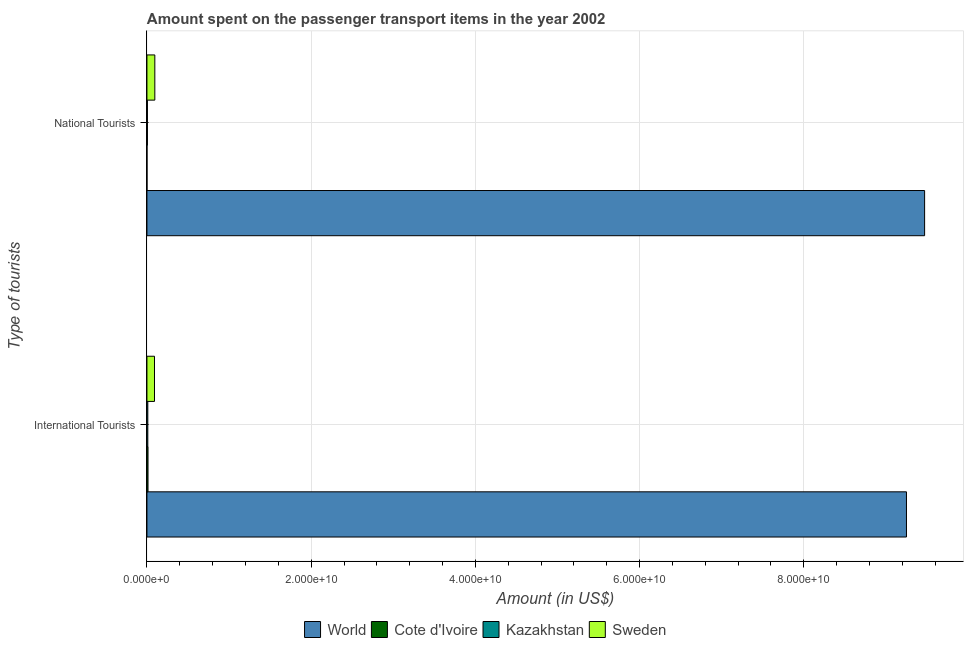How many different coloured bars are there?
Provide a short and direct response. 4. How many groups of bars are there?
Give a very brief answer. 2. How many bars are there on the 2nd tick from the top?
Keep it short and to the point. 4. How many bars are there on the 2nd tick from the bottom?
Give a very brief answer. 4. What is the label of the 1st group of bars from the top?
Offer a terse response. National Tourists. What is the amount spent on transport items of national tourists in Kazakhstan?
Your answer should be compact. 5.80e+07. Across all countries, what is the maximum amount spent on transport items of national tourists?
Give a very brief answer. 9.47e+1. Across all countries, what is the minimum amount spent on transport items of international tourists?
Give a very brief answer. 1.06e+08. In which country was the amount spent on transport items of international tourists maximum?
Provide a short and direct response. World. In which country was the amount spent on transport items of international tourists minimum?
Provide a succinct answer. Kazakhstan. What is the total amount spent on transport items of national tourists in the graph?
Provide a short and direct response. 9.57e+1. What is the difference between the amount spent on transport items of international tourists in Kazakhstan and that in Sweden?
Offer a very short reply. -8.14e+08. What is the difference between the amount spent on transport items of international tourists in World and the amount spent on transport items of national tourists in Cote d'Ivoire?
Your answer should be compact. 9.25e+1. What is the average amount spent on transport items of international tourists per country?
Give a very brief answer. 2.34e+1. What is the difference between the amount spent on transport items of national tourists and amount spent on transport items of international tourists in Sweden?
Your answer should be very brief. 4.10e+07. In how many countries, is the amount spent on transport items of national tourists greater than 16000000000 US$?
Provide a short and direct response. 1. What is the ratio of the amount spent on transport items of international tourists in World to that in Kazakhstan?
Give a very brief answer. 872.7. Is the amount spent on transport items of international tourists in Sweden less than that in Cote d'Ivoire?
Offer a terse response. No. In how many countries, is the amount spent on transport items of national tourists greater than the average amount spent on transport items of national tourists taken over all countries?
Your answer should be very brief. 1. What does the 3rd bar from the top in National Tourists represents?
Your answer should be compact. Cote d'Ivoire. How many bars are there?
Your answer should be very brief. 8. How many countries are there in the graph?
Ensure brevity in your answer.  4. What is the difference between two consecutive major ticks on the X-axis?
Your answer should be compact. 2.00e+1. Are the values on the major ticks of X-axis written in scientific E-notation?
Ensure brevity in your answer.  Yes. Does the graph contain grids?
Offer a very short reply. Yes. Where does the legend appear in the graph?
Offer a terse response. Bottom center. How are the legend labels stacked?
Make the answer very short. Horizontal. What is the title of the graph?
Give a very brief answer. Amount spent on the passenger transport items in the year 2002. Does "Canada" appear as one of the legend labels in the graph?
Keep it short and to the point. No. What is the label or title of the X-axis?
Your answer should be compact. Amount (in US$). What is the label or title of the Y-axis?
Give a very brief answer. Type of tourists. What is the Amount (in US$) in World in International Tourists?
Offer a very short reply. 9.25e+1. What is the Amount (in US$) in Cote d'Ivoire in International Tourists?
Your answer should be compact. 1.32e+08. What is the Amount (in US$) of Kazakhstan in International Tourists?
Make the answer very short. 1.06e+08. What is the Amount (in US$) of Sweden in International Tourists?
Keep it short and to the point. 9.20e+08. What is the Amount (in US$) of World in National Tourists?
Your answer should be very brief. 9.47e+1. What is the Amount (in US$) in Cote d'Ivoire in National Tourists?
Give a very brief answer. 5.00e+06. What is the Amount (in US$) in Kazakhstan in National Tourists?
Keep it short and to the point. 5.80e+07. What is the Amount (in US$) of Sweden in National Tourists?
Give a very brief answer. 9.61e+08. Across all Type of tourists, what is the maximum Amount (in US$) of World?
Provide a succinct answer. 9.47e+1. Across all Type of tourists, what is the maximum Amount (in US$) in Cote d'Ivoire?
Provide a short and direct response. 1.32e+08. Across all Type of tourists, what is the maximum Amount (in US$) of Kazakhstan?
Keep it short and to the point. 1.06e+08. Across all Type of tourists, what is the maximum Amount (in US$) of Sweden?
Offer a terse response. 9.61e+08. Across all Type of tourists, what is the minimum Amount (in US$) in World?
Keep it short and to the point. 9.25e+1. Across all Type of tourists, what is the minimum Amount (in US$) of Cote d'Ivoire?
Offer a very short reply. 5.00e+06. Across all Type of tourists, what is the minimum Amount (in US$) of Kazakhstan?
Make the answer very short. 5.80e+07. Across all Type of tourists, what is the minimum Amount (in US$) in Sweden?
Give a very brief answer. 9.20e+08. What is the total Amount (in US$) in World in the graph?
Offer a very short reply. 1.87e+11. What is the total Amount (in US$) in Cote d'Ivoire in the graph?
Ensure brevity in your answer.  1.37e+08. What is the total Amount (in US$) in Kazakhstan in the graph?
Give a very brief answer. 1.64e+08. What is the total Amount (in US$) in Sweden in the graph?
Your answer should be very brief. 1.88e+09. What is the difference between the Amount (in US$) in World in International Tourists and that in National Tourists?
Your response must be concise. -2.21e+09. What is the difference between the Amount (in US$) of Cote d'Ivoire in International Tourists and that in National Tourists?
Give a very brief answer. 1.27e+08. What is the difference between the Amount (in US$) in Kazakhstan in International Tourists and that in National Tourists?
Offer a terse response. 4.80e+07. What is the difference between the Amount (in US$) in Sweden in International Tourists and that in National Tourists?
Give a very brief answer. -4.10e+07. What is the difference between the Amount (in US$) in World in International Tourists and the Amount (in US$) in Cote d'Ivoire in National Tourists?
Give a very brief answer. 9.25e+1. What is the difference between the Amount (in US$) in World in International Tourists and the Amount (in US$) in Kazakhstan in National Tourists?
Offer a terse response. 9.24e+1. What is the difference between the Amount (in US$) in World in International Tourists and the Amount (in US$) in Sweden in National Tourists?
Keep it short and to the point. 9.15e+1. What is the difference between the Amount (in US$) in Cote d'Ivoire in International Tourists and the Amount (in US$) in Kazakhstan in National Tourists?
Keep it short and to the point. 7.40e+07. What is the difference between the Amount (in US$) in Cote d'Ivoire in International Tourists and the Amount (in US$) in Sweden in National Tourists?
Provide a succinct answer. -8.29e+08. What is the difference between the Amount (in US$) of Kazakhstan in International Tourists and the Amount (in US$) of Sweden in National Tourists?
Ensure brevity in your answer.  -8.55e+08. What is the average Amount (in US$) of World per Type of tourists?
Your response must be concise. 9.36e+1. What is the average Amount (in US$) of Cote d'Ivoire per Type of tourists?
Your answer should be very brief. 6.85e+07. What is the average Amount (in US$) of Kazakhstan per Type of tourists?
Provide a short and direct response. 8.20e+07. What is the average Amount (in US$) in Sweden per Type of tourists?
Give a very brief answer. 9.40e+08. What is the difference between the Amount (in US$) in World and Amount (in US$) in Cote d'Ivoire in International Tourists?
Your answer should be compact. 9.24e+1. What is the difference between the Amount (in US$) of World and Amount (in US$) of Kazakhstan in International Tourists?
Keep it short and to the point. 9.24e+1. What is the difference between the Amount (in US$) of World and Amount (in US$) of Sweden in International Tourists?
Keep it short and to the point. 9.16e+1. What is the difference between the Amount (in US$) in Cote d'Ivoire and Amount (in US$) in Kazakhstan in International Tourists?
Offer a terse response. 2.60e+07. What is the difference between the Amount (in US$) in Cote d'Ivoire and Amount (in US$) in Sweden in International Tourists?
Offer a very short reply. -7.88e+08. What is the difference between the Amount (in US$) in Kazakhstan and Amount (in US$) in Sweden in International Tourists?
Offer a terse response. -8.14e+08. What is the difference between the Amount (in US$) in World and Amount (in US$) in Cote d'Ivoire in National Tourists?
Make the answer very short. 9.47e+1. What is the difference between the Amount (in US$) in World and Amount (in US$) in Kazakhstan in National Tourists?
Your answer should be very brief. 9.47e+1. What is the difference between the Amount (in US$) in World and Amount (in US$) in Sweden in National Tourists?
Provide a short and direct response. 9.38e+1. What is the difference between the Amount (in US$) in Cote d'Ivoire and Amount (in US$) in Kazakhstan in National Tourists?
Ensure brevity in your answer.  -5.30e+07. What is the difference between the Amount (in US$) in Cote d'Ivoire and Amount (in US$) in Sweden in National Tourists?
Your answer should be very brief. -9.56e+08. What is the difference between the Amount (in US$) in Kazakhstan and Amount (in US$) in Sweden in National Tourists?
Your answer should be compact. -9.03e+08. What is the ratio of the Amount (in US$) of World in International Tourists to that in National Tourists?
Offer a terse response. 0.98. What is the ratio of the Amount (in US$) of Cote d'Ivoire in International Tourists to that in National Tourists?
Ensure brevity in your answer.  26.4. What is the ratio of the Amount (in US$) in Kazakhstan in International Tourists to that in National Tourists?
Keep it short and to the point. 1.83. What is the ratio of the Amount (in US$) of Sweden in International Tourists to that in National Tourists?
Make the answer very short. 0.96. What is the difference between the highest and the second highest Amount (in US$) of World?
Ensure brevity in your answer.  2.21e+09. What is the difference between the highest and the second highest Amount (in US$) of Cote d'Ivoire?
Keep it short and to the point. 1.27e+08. What is the difference between the highest and the second highest Amount (in US$) in Kazakhstan?
Ensure brevity in your answer.  4.80e+07. What is the difference between the highest and the second highest Amount (in US$) of Sweden?
Offer a very short reply. 4.10e+07. What is the difference between the highest and the lowest Amount (in US$) in World?
Provide a succinct answer. 2.21e+09. What is the difference between the highest and the lowest Amount (in US$) in Cote d'Ivoire?
Provide a succinct answer. 1.27e+08. What is the difference between the highest and the lowest Amount (in US$) of Kazakhstan?
Offer a very short reply. 4.80e+07. What is the difference between the highest and the lowest Amount (in US$) of Sweden?
Provide a short and direct response. 4.10e+07. 